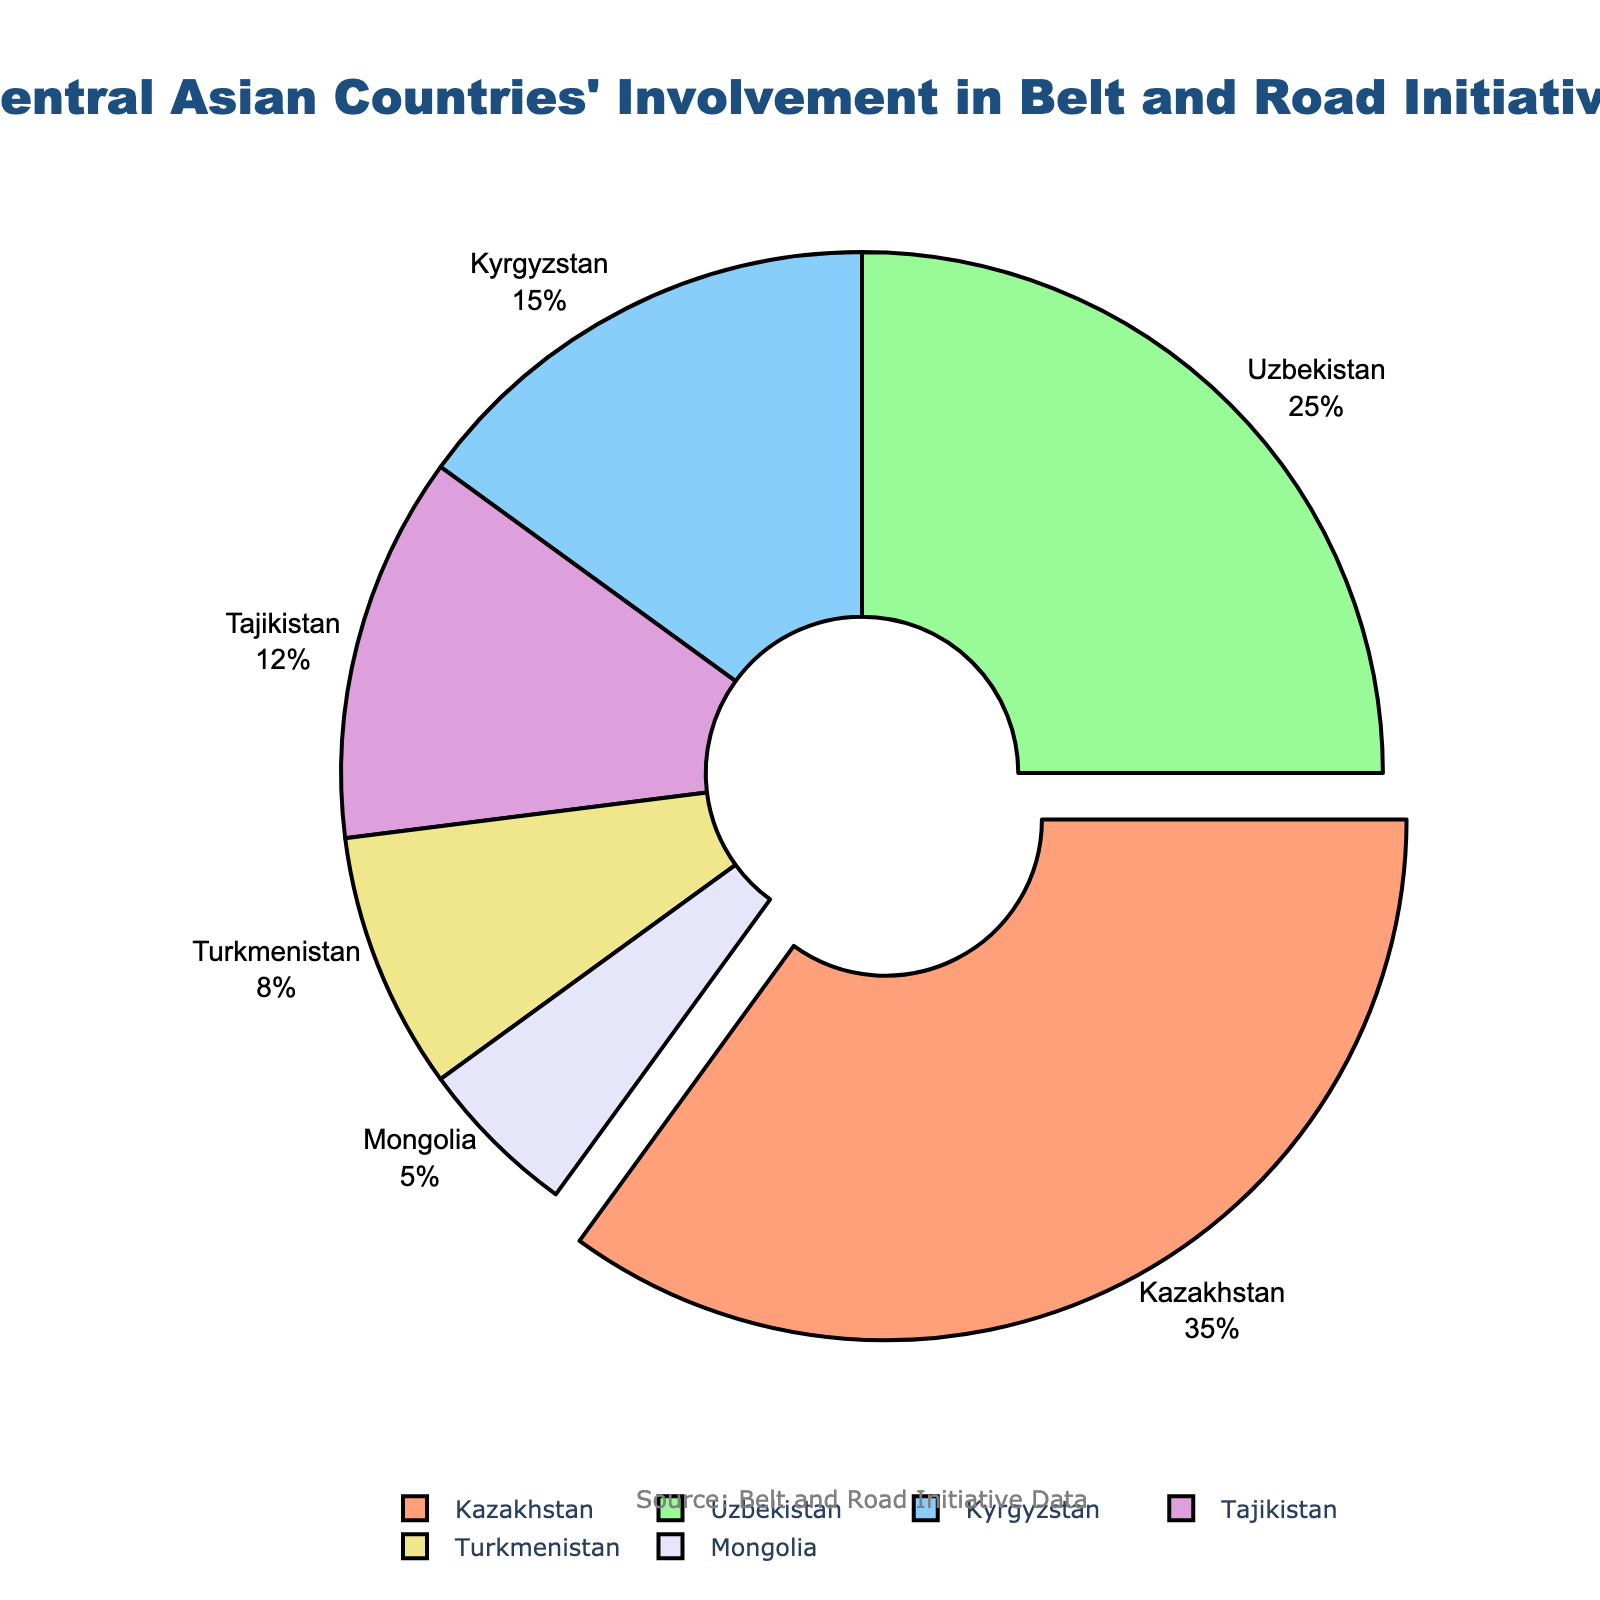Which country has the highest involvement in the Belt and Road Initiative? By looking at the pie chart, we see that Kazakhstan has the largest segment, which is also pulled out from the rest of the pie chart to highlight its significance. Kazakhstan's involvement is 35%.
Answer: Kazakhstan How much more involvement does Kazakhstan have compared to Uzbekistan? According to the pie chart, Kazakhstan’s involvement is 35%, and Uzbekistan’s involvement is 25%. The difference between them is a simple subtraction: 35% - 25% = 10%.
Answer: 10% What is the combined involvement of Kyrgyzstan, Tajikistan, and Turkmenistan in the Belt and Road Initiative? By adding the percentages of Kyrgyzstan (15%), Tajikistan (12%), and Turkmenistan (8%), we get 15% + 12% + 8% = 35%.
Answer: 35% Which country has the smallest involvement, and what is its percentage? By observing the pie chart, Mongolia has the smallest segment, indicating it has the lowest involvement of 5%.
Answer: Mongolia, 5% What is the visual distinction of Kazakhstan’s segment in the chart? The segment representing Kazakhstan is pulled out from the center of the pie, making it visually distinct from the other segments. Additionally, it uses a different color compared to its neighboring segments.
Answer: Pulled out segment Which two countries together have an involvement equal to Kazakhstan? Kazakhstan has an involvement of 35%. Combining the percentages of Uzbekistan (25%) and Turkmenistan (8%), we get 25% + 8% = 33%. This is not sufficient. However, combining Uzbekistan (25%) and Kyrgyzstan (15%) results in 25% + 15% = 40%, which exceeds Kazakhstan's involvement. Therefore, the closest pair is Uzbekistan and Kyrgyzstan.
Answer: Uzbekistan and Kyrgyzstan Out of all the countries, which two together have the lowest combined involvement, and what is their total? The two countries with the lowest involvement are Mongolia (5%) and Turkmenistan (8%). Their combined involvement is 5% + 8% = 13%.
Answer: Mongolia and Turkmenistan, 13% How many countries have an involvement of 15% or higher in the Belt and Road Initiative? By looking at the pie chart, Kazakhstan (35%), Uzbekistan (25%), and Kyrgyzstan (15%) meet or exceed the threshold of 15%. Therefore, there are three countries.
Answer: 3 What is the average involvement of all the countries listed in the chart? First, sum the percentages of all countries: (35 + 25 + 15 + 12 + 8 + 5 = 100). Since there are six countries, the average involvement is 100% / 6 ≈ 16.67%.
Answer: 16.67% Which country has an involvement closest to the average involvement of all countries? From the calculated average involvement of approximately 16.67%, we compare it to the listed percentages. Kyrgyzstan, with 15%, is the closest to the average.
Answer: Kyrgyzstan 